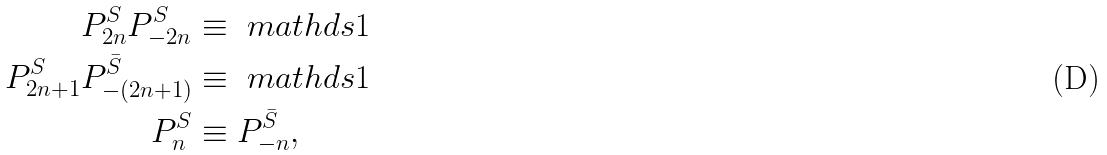Convert formula to latex. <formula><loc_0><loc_0><loc_500><loc_500>P ^ { S } _ { 2 n } P ^ { S } _ { - 2 n } & \equiv \ m a t h d s { 1 } \\ P ^ { S } _ { 2 n + 1 } P ^ { \bar { S } } _ { - ( 2 n + 1 ) } & \equiv \ m a t h d s { 1 } \\ P ^ { S } _ { n } & \equiv P ^ { \bar { S } } _ { - n } ,</formula> 